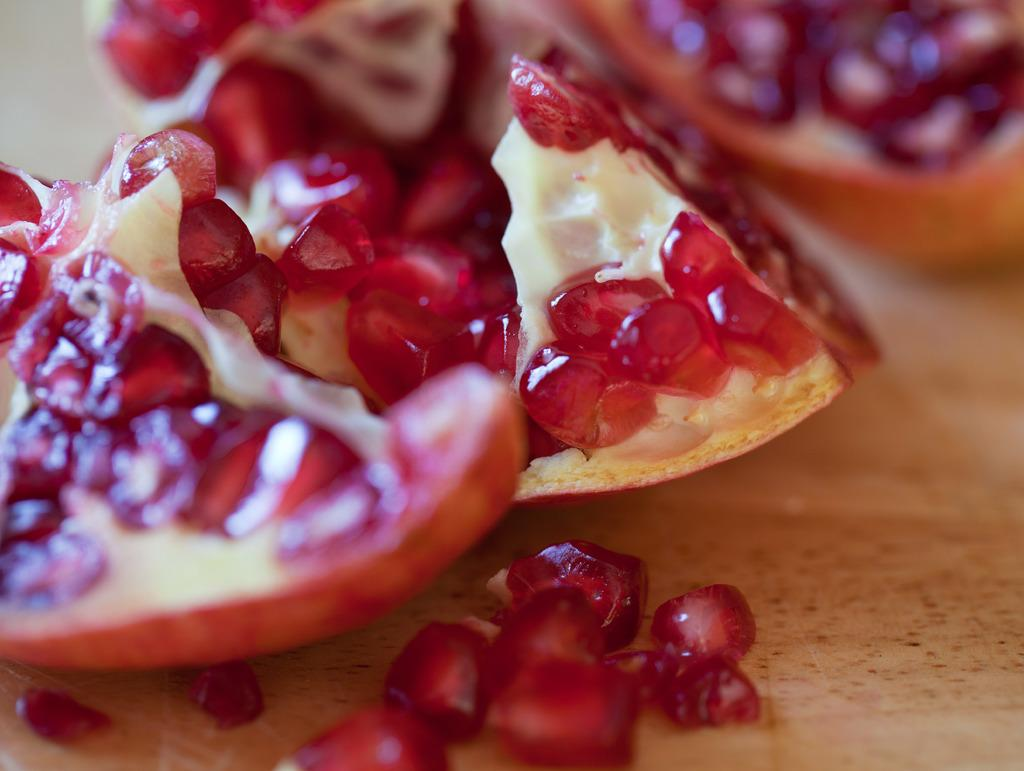What fruit is present in the image? There is a pomegranate in the image. What is inside the pomegranate? The pomegranate has seeds. Where are the pomegranate and its seeds located? The pomegranate and its seeds are placed on a table. What color is the light bulb in the image? There is no light bulb present in the image. 